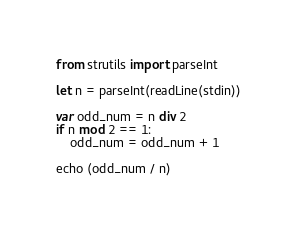Convert code to text. <code><loc_0><loc_0><loc_500><loc_500><_Nim_>from strutils import parseInt

let n = parseInt(readLine(stdin))

var odd_num = n div 2
if n mod 2 == 1:
    odd_num = odd_num + 1

echo (odd_num / n)
</code> 